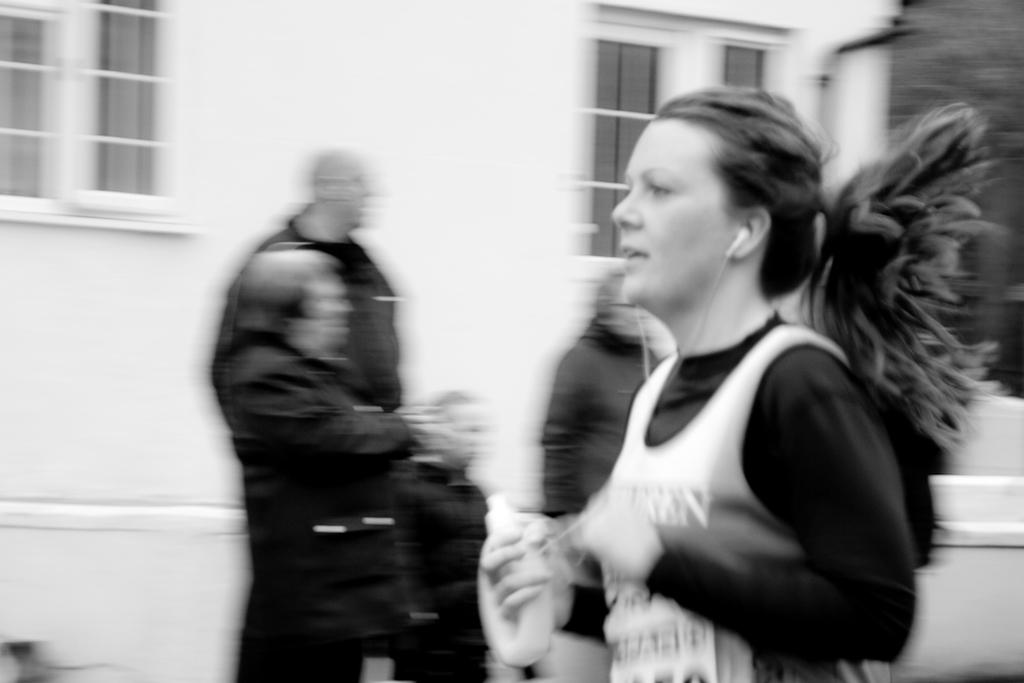Who is the main subject in the image? There is a girl in the image. What is the girl wearing? The girl is wearing a black t-shirt. What is the girl doing in the image? The girl is running on the road. What can be seen in the background of the image? There is a white house and a man with a small girl standing in the background of the image. What type of bird is flying over the girl in the image? There is no bird present in the image. Can you tell me how many giraffes are visible in the background of the image? There are no giraffes present in the image. 